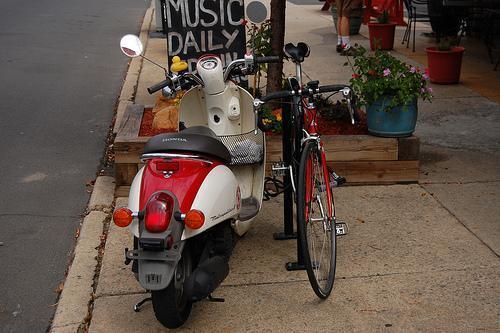How many bicycles are there?
Give a very brief answer. 1. 